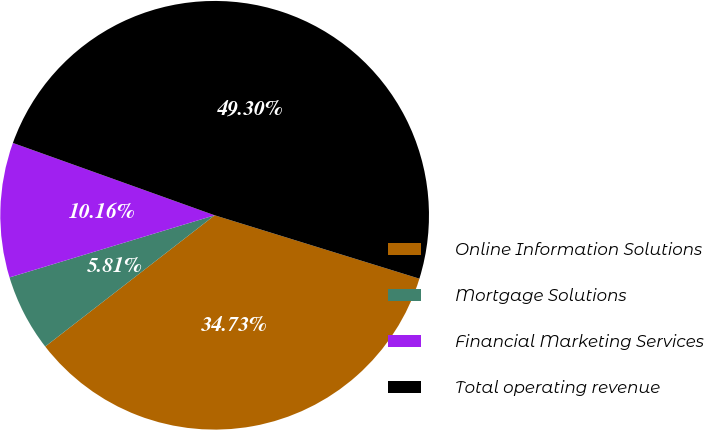<chart> <loc_0><loc_0><loc_500><loc_500><pie_chart><fcel>Online Information Solutions<fcel>Mortgage Solutions<fcel>Financial Marketing Services<fcel>Total operating revenue<nl><fcel>34.73%<fcel>5.81%<fcel>10.16%<fcel>49.3%<nl></chart> 